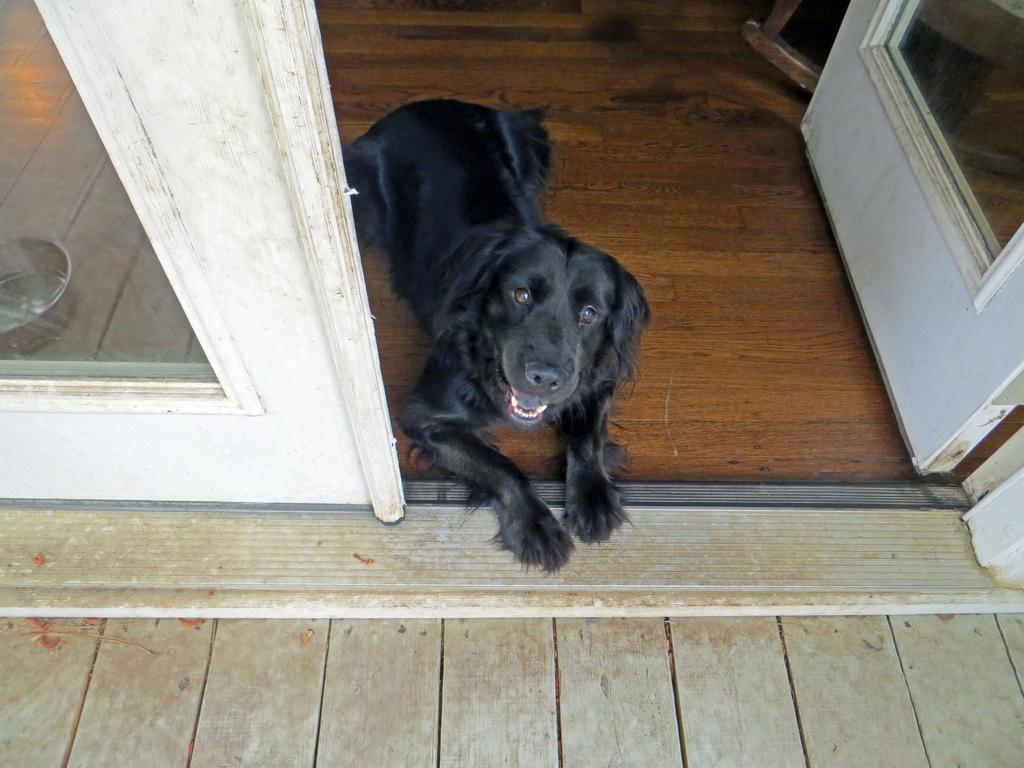What type of animal is in the image? There is a dog in the image. What color is the dog? The dog is black in color. What else can be seen in the image besides the dog? There is a container, a wooden floor, and a door in the image. What type of drug is the dog taking in the image? There is no drug present in the image; it is a black dog on a wooden floor with a container and a door. 